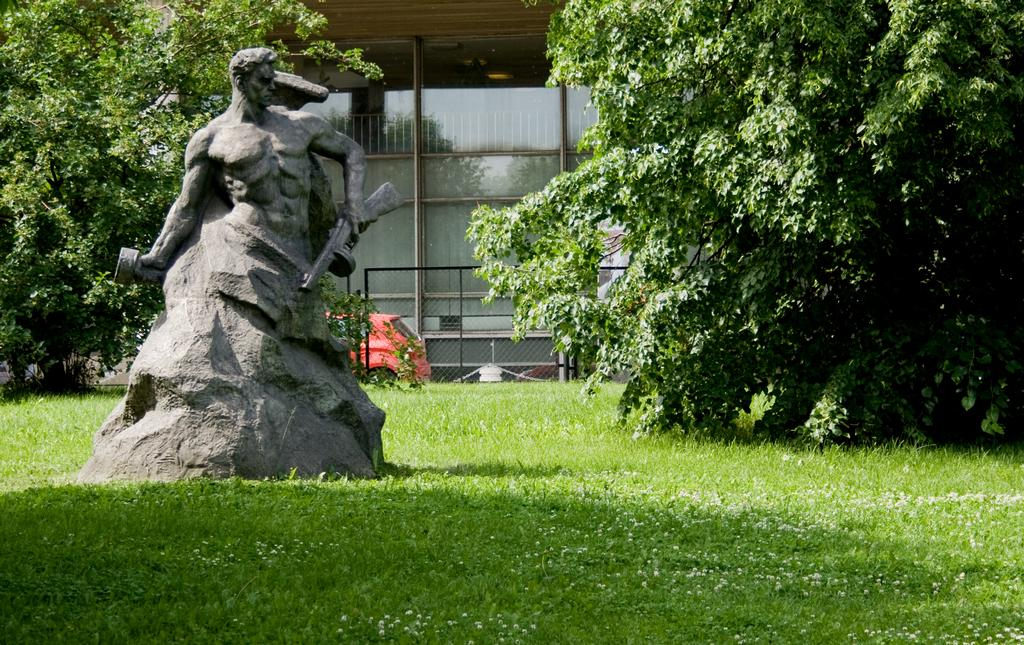What type of objects can be seen in the image? There are statues in the image. What type of natural environment is visible in the image? There is grass, trees, and a building in the image. What type of man-made structure is present in the image? There is a fence in the image. What type of vehicle is visible in the image? There is a red color car in the image. What type of lace can be seen on the statues in the image? There is no lace present on the statues in the image. What type of school is depicted in the image? There is no school depicted in the image. What type of gun is visible in the image? There is no gun visible in the image. 